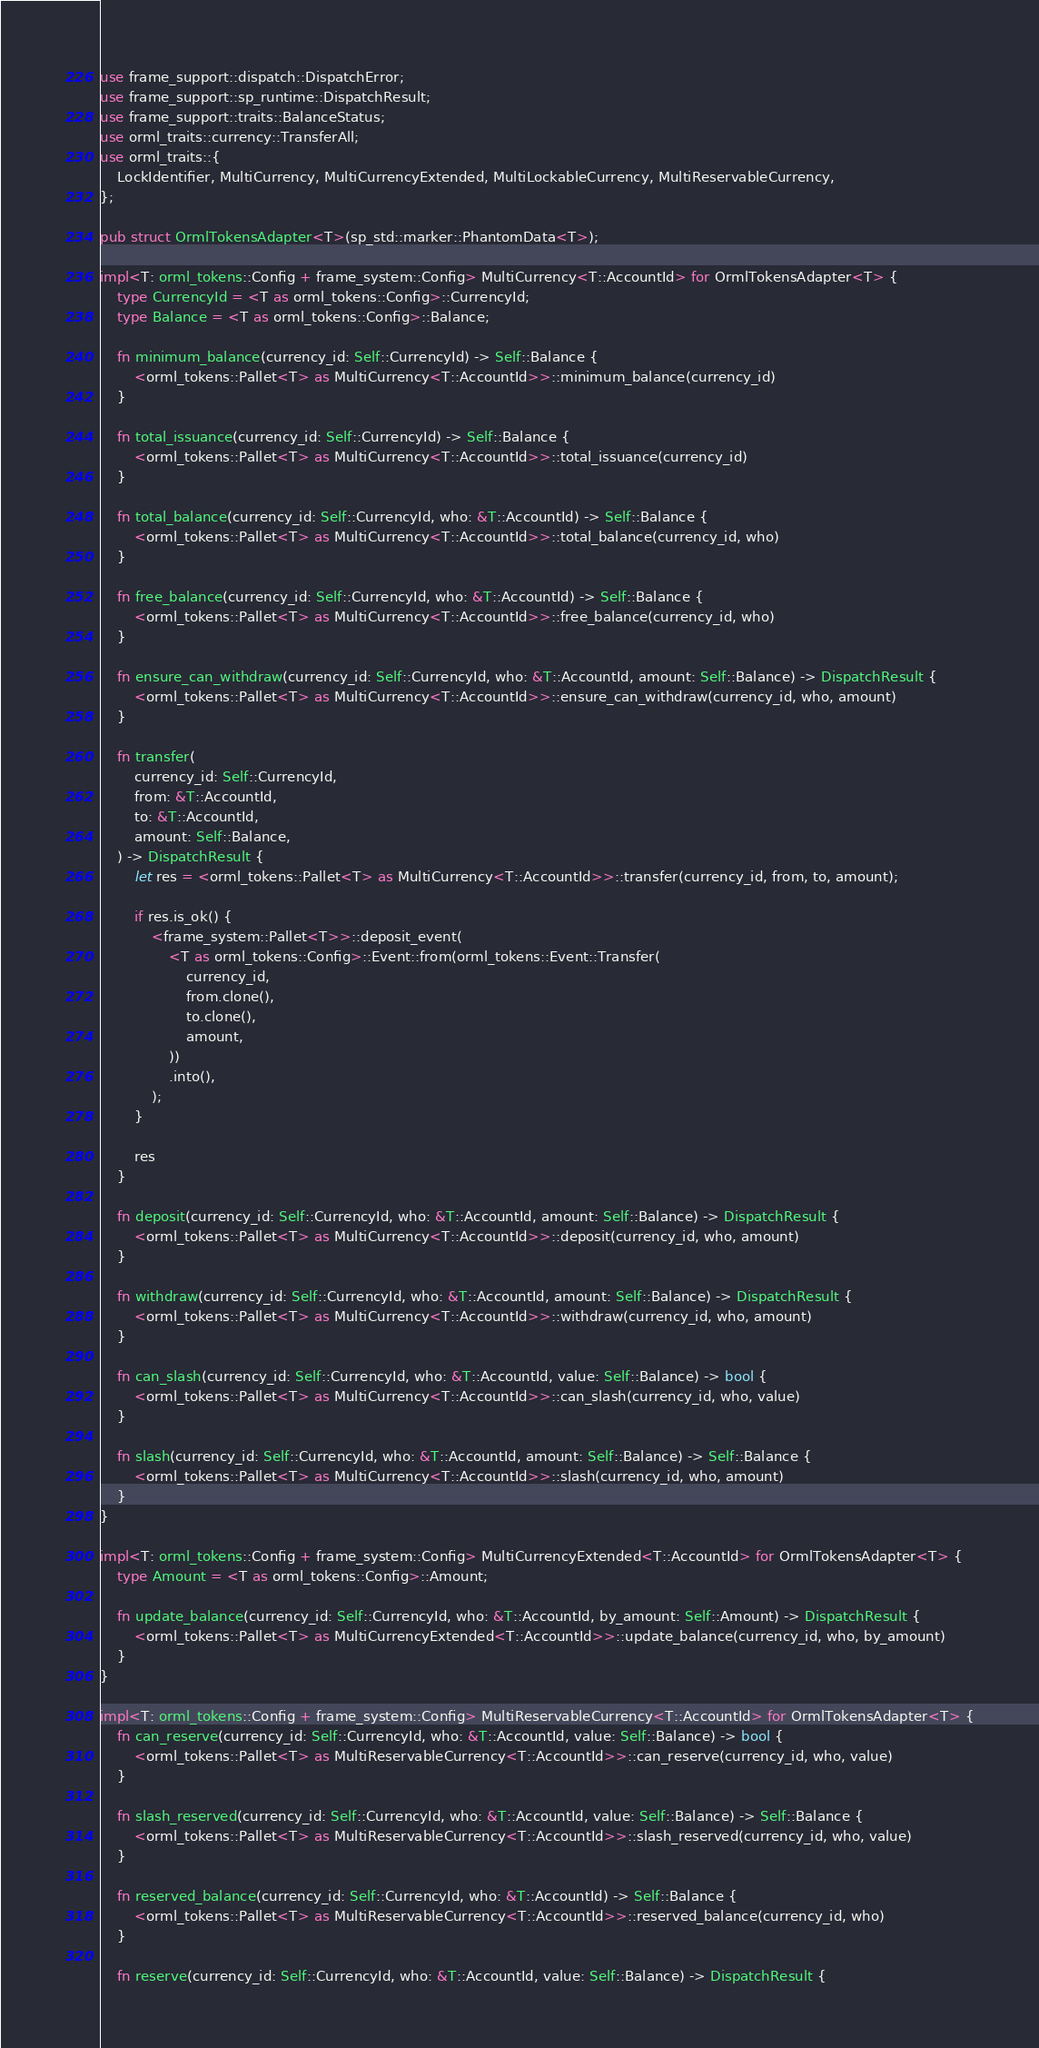<code> <loc_0><loc_0><loc_500><loc_500><_Rust_>use frame_support::dispatch::DispatchError;
use frame_support::sp_runtime::DispatchResult;
use frame_support::traits::BalanceStatus;
use orml_traits::currency::TransferAll;
use orml_traits::{
	LockIdentifier, MultiCurrency, MultiCurrencyExtended, MultiLockableCurrency, MultiReservableCurrency,
};

pub struct OrmlTokensAdapter<T>(sp_std::marker::PhantomData<T>);

impl<T: orml_tokens::Config + frame_system::Config> MultiCurrency<T::AccountId> for OrmlTokensAdapter<T> {
	type CurrencyId = <T as orml_tokens::Config>::CurrencyId;
	type Balance = <T as orml_tokens::Config>::Balance;

	fn minimum_balance(currency_id: Self::CurrencyId) -> Self::Balance {
		<orml_tokens::Pallet<T> as MultiCurrency<T::AccountId>>::minimum_balance(currency_id)
	}

	fn total_issuance(currency_id: Self::CurrencyId) -> Self::Balance {
		<orml_tokens::Pallet<T> as MultiCurrency<T::AccountId>>::total_issuance(currency_id)
	}

	fn total_balance(currency_id: Self::CurrencyId, who: &T::AccountId) -> Self::Balance {
		<orml_tokens::Pallet<T> as MultiCurrency<T::AccountId>>::total_balance(currency_id, who)
	}

	fn free_balance(currency_id: Self::CurrencyId, who: &T::AccountId) -> Self::Balance {
		<orml_tokens::Pallet<T> as MultiCurrency<T::AccountId>>::free_balance(currency_id, who)
	}

	fn ensure_can_withdraw(currency_id: Self::CurrencyId, who: &T::AccountId, amount: Self::Balance) -> DispatchResult {
		<orml_tokens::Pallet<T> as MultiCurrency<T::AccountId>>::ensure_can_withdraw(currency_id, who, amount)
	}

	fn transfer(
		currency_id: Self::CurrencyId,
		from: &T::AccountId,
		to: &T::AccountId,
		amount: Self::Balance,
	) -> DispatchResult {
		let res = <orml_tokens::Pallet<T> as MultiCurrency<T::AccountId>>::transfer(currency_id, from, to, amount);

		if res.is_ok() {
			<frame_system::Pallet<T>>::deposit_event(
				<T as orml_tokens::Config>::Event::from(orml_tokens::Event::Transfer(
					currency_id,
					from.clone(),
					to.clone(),
					amount,
				))
				.into(),
			);
		}

		res
	}

	fn deposit(currency_id: Self::CurrencyId, who: &T::AccountId, amount: Self::Balance) -> DispatchResult {
		<orml_tokens::Pallet<T> as MultiCurrency<T::AccountId>>::deposit(currency_id, who, amount)
	}

	fn withdraw(currency_id: Self::CurrencyId, who: &T::AccountId, amount: Self::Balance) -> DispatchResult {
		<orml_tokens::Pallet<T> as MultiCurrency<T::AccountId>>::withdraw(currency_id, who, amount)
	}

	fn can_slash(currency_id: Self::CurrencyId, who: &T::AccountId, value: Self::Balance) -> bool {
		<orml_tokens::Pallet<T> as MultiCurrency<T::AccountId>>::can_slash(currency_id, who, value)
	}

	fn slash(currency_id: Self::CurrencyId, who: &T::AccountId, amount: Self::Balance) -> Self::Balance {
		<orml_tokens::Pallet<T> as MultiCurrency<T::AccountId>>::slash(currency_id, who, amount)
	}
}

impl<T: orml_tokens::Config + frame_system::Config> MultiCurrencyExtended<T::AccountId> for OrmlTokensAdapter<T> {
	type Amount = <T as orml_tokens::Config>::Amount;

	fn update_balance(currency_id: Self::CurrencyId, who: &T::AccountId, by_amount: Self::Amount) -> DispatchResult {
		<orml_tokens::Pallet<T> as MultiCurrencyExtended<T::AccountId>>::update_balance(currency_id, who, by_amount)
	}
}

impl<T: orml_tokens::Config + frame_system::Config> MultiReservableCurrency<T::AccountId> for OrmlTokensAdapter<T> {
	fn can_reserve(currency_id: Self::CurrencyId, who: &T::AccountId, value: Self::Balance) -> bool {
		<orml_tokens::Pallet<T> as MultiReservableCurrency<T::AccountId>>::can_reserve(currency_id, who, value)
	}

	fn slash_reserved(currency_id: Self::CurrencyId, who: &T::AccountId, value: Self::Balance) -> Self::Balance {
		<orml_tokens::Pallet<T> as MultiReservableCurrency<T::AccountId>>::slash_reserved(currency_id, who, value)
	}

	fn reserved_balance(currency_id: Self::CurrencyId, who: &T::AccountId) -> Self::Balance {
		<orml_tokens::Pallet<T> as MultiReservableCurrency<T::AccountId>>::reserved_balance(currency_id, who)
	}

	fn reserve(currency_id: Self::CurrencyId, who: &T::AccountId, value: Self::Balance) -> DispatchResult {</code> 